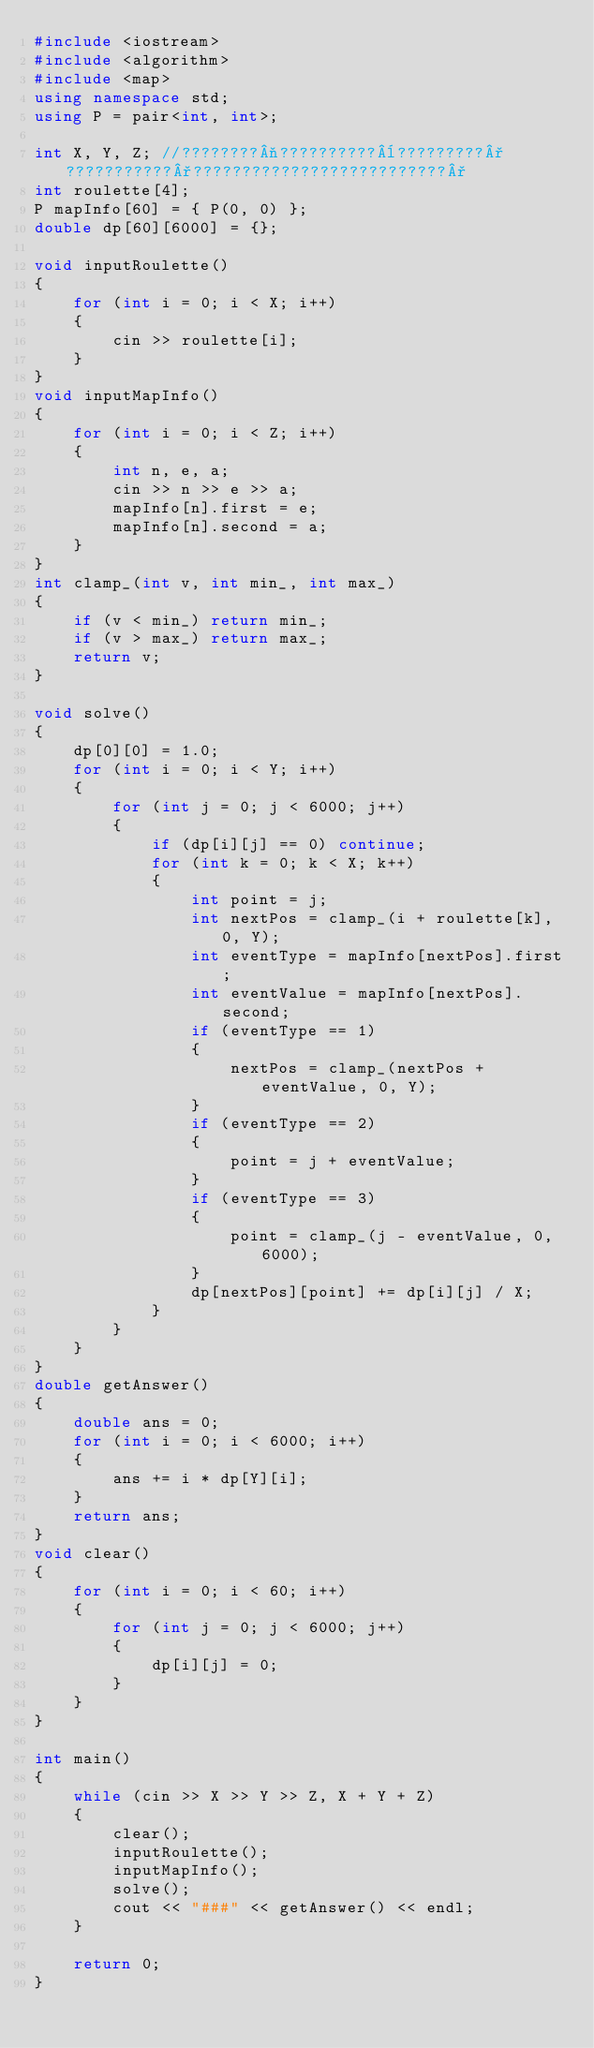<code> <loc_0><loc_0><loc_500><loc_500><_C++_>#include <iostream>
#include <algorithm>
#include <map>
using namespace std;
using P = pair<int, int>;

int X, Y, Z; //????????¬??????????¨?????????°???????????°??????????????????????????°
int roulette[4];
P mapInfo[60] = { P(0, 0) };
double dp[60][6000] = {};

void inputRoulette()
{
	for (int i = 0; i < X; i++)
	{
		cin >> roulette[i];
	}
}
void inputMapInfo()
{
	for (int i = 0; i < Z; i++)
	{
		int n, e, a;
		cin >> n >> e >> a;
		mapInfo[n].first = e;
		mapInfo[n].second = a;
	}
}
int clamp_(int v, int min_, int max_)
{
	if (v < min_) return min_;
	if (v > max_) return max_;
	return v;
}

void solve()
{
	dp[0][0] = 1.0;
	for (int i = 0; i < Y; i++)
	{
		for (int j = 0; j < 6000; j++)
		{
			if (dp[i][j] == 0) continue;
			for (int k = 0; k < X; k++)
			{
				int point = j;
				int nextPos = clamp_(i + roulette[k], 0, Y);
				int eventType = mapInfo[nextPos].first;
				int eventValue = mapInfo[nextPos].second;
				if (eventType == 1)
				{
					nextPos = clamp_(nextPos + eventValue, 0, Y);
				}
				if (eventType == 2)
				{
					point = j + eventValue;
				}
				if (eventType == 3)
				{
					point = clamp_(j - eventValue, 0, 6000);
				}
				dp[nextPos][point] += dp[i][j] / X;
			}
		}
	}
}
double getAnswer()
{
	double ans = 0;
	for (int i = 0; i < 6000; i++)
	{
		ans += i * dp[Y][i];
	}
	return ans;
}
void clear()
{
	for (int i = 0; i < 60; i++)
	{
		for (int j = 0; j < 6000; j++)
		{
			dp[i][j] = 0;
		}
	}
}

int main()
{
	while (cin >> X >> Y >> Z, X + Y + Z)
	{
		clear();
		inputRoulette();
		inputMapInfo();
		solve();
		cout << "###" << getAnswer() << endl;
	}

	return 0;
}</code> 